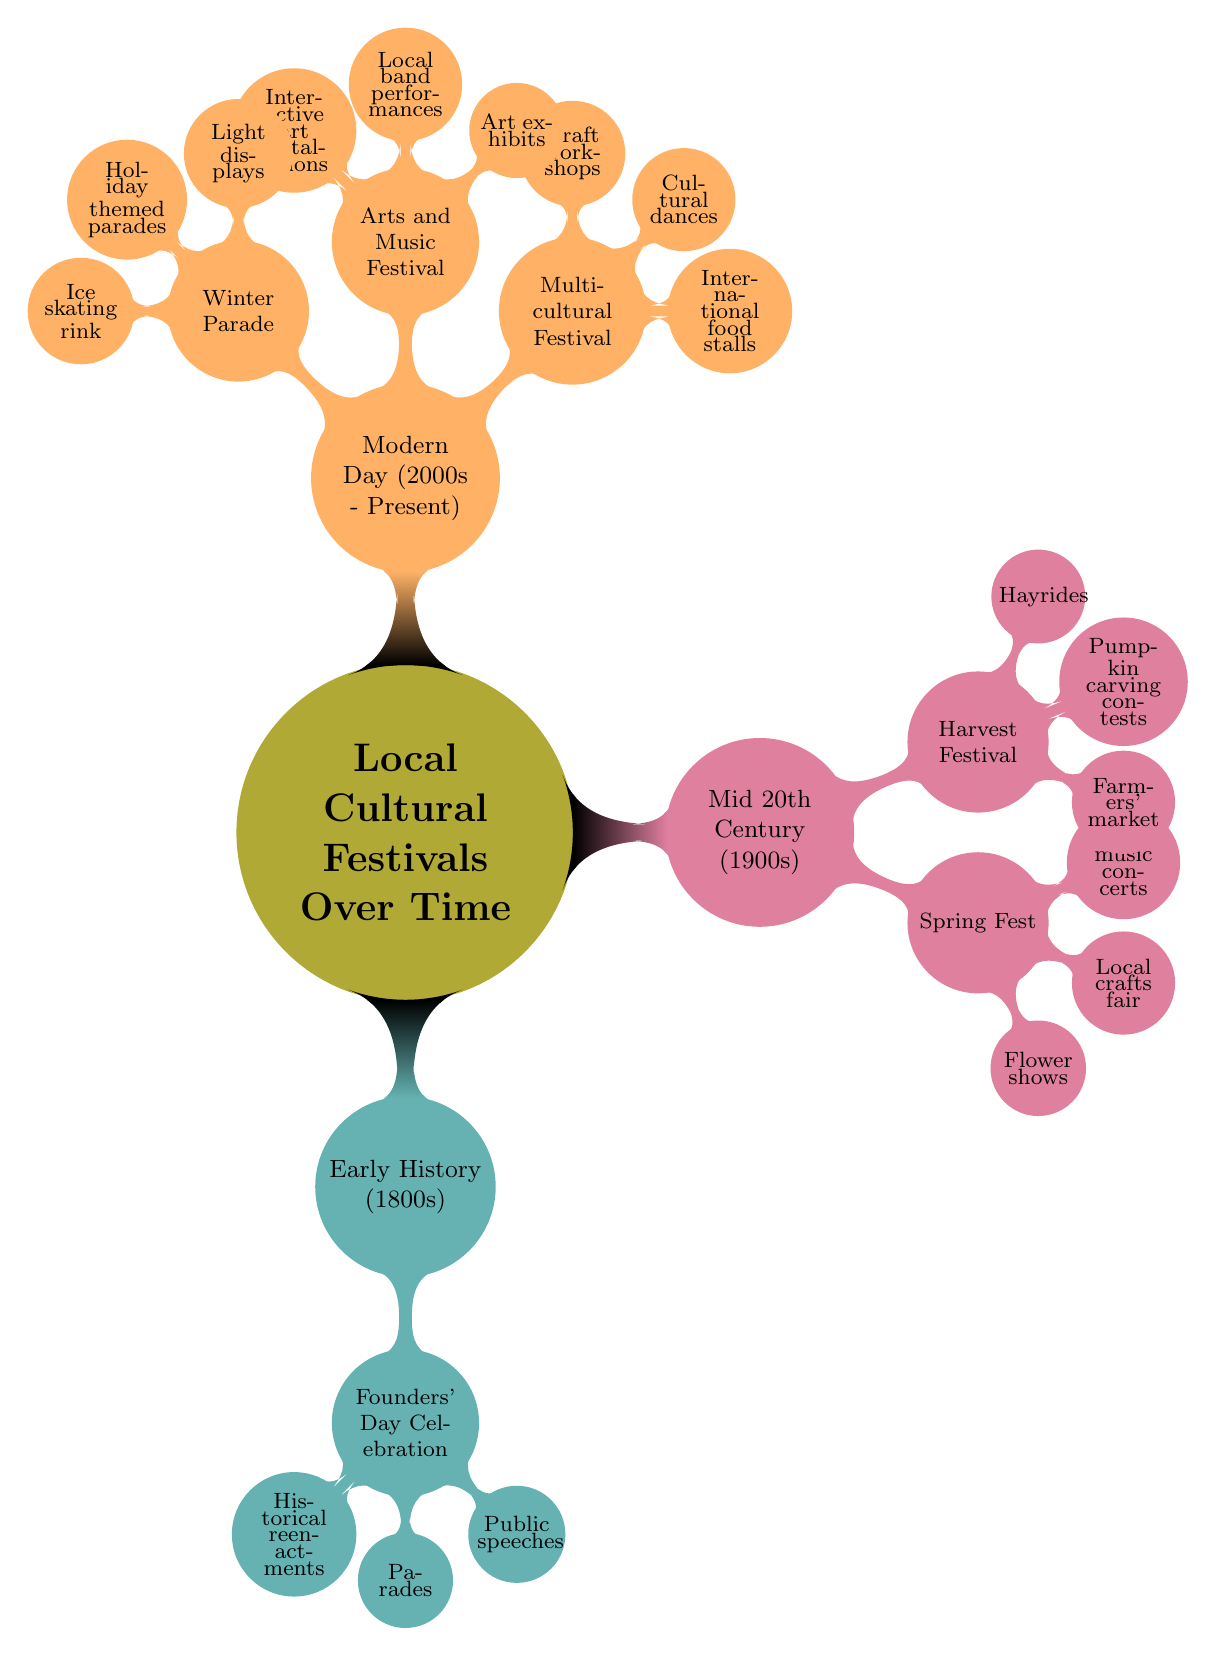What cultural festival is celebrated in the early history (1800s)? The diagram shows that the cultural festival celebrated in the early history (1800s) is the Founders' Day Celebration. It is the only festival listed under that category in the diagram.
Answer: Founders' Day Celebration How many key activities are there for the Arts and Music Festival? By examining the node for the Arts and Music Festival, it lists three key activities (Art exhibits, Local band performances, Interactive art installations). Therefore, the total number of key activities under this festival is three.
Answer: 3 What is the main theme of the Multicultural Festival? The diagram indicates that the Multicultural Festival showcases the town's diverse cultural heritage, which is its main theme as described in the node.
Answer: Diverse cultural heritage Which festival involves historical reenactments? The diagram specifies that the Founders' Day Celebration involves historical reenactments. This is indicated in the details listed under that specific festival node.
Answer: Founders' Day Celebration How do you identify the festival that celebrates springtime? The Spring Fest node under the Mid 20th Century category specifically mentions in its description that it is a celebration of springtime and local flora, making it identifiable by its focus on these themes.
Answer: Spring Fest Which era features the Winter Parade? In the diagram, the Winter Parade is listed under the Modern Day (2000s - Present) category, thus identifying it with that specific time period.
Answer: Modern Day (2000s - Present) What activity is NOT listed for the Harvest Festival? By checking the key activities listed under the Harvest Festival, which includes Farmers' market, Pumpkin carving contests, and Hayrides, it can be concluded that any activity not mentioned here does not pertain to this festival. For instance, light displays are not listed, making them a non-option.
Answer: Light displays What are the two festivals in the Mid 20th Century? The diagram clearly shows two festivals in the Mid 20th Century section: Spring Fest and Harvest Festival. By counting these nodes, we can identify them accurately.
Answer: Spring Fest, Harvest Festival What activity is unique to the Winter Parade? The diagram states that the Winter Parade includes key activities such as Light displays, Holiday themed parades, and Ice skating rink. Among these, Ice skating rink is distinctive and commonly associated with winter festivities, thus making it unique to this event.
Answer: Ice skating rink 